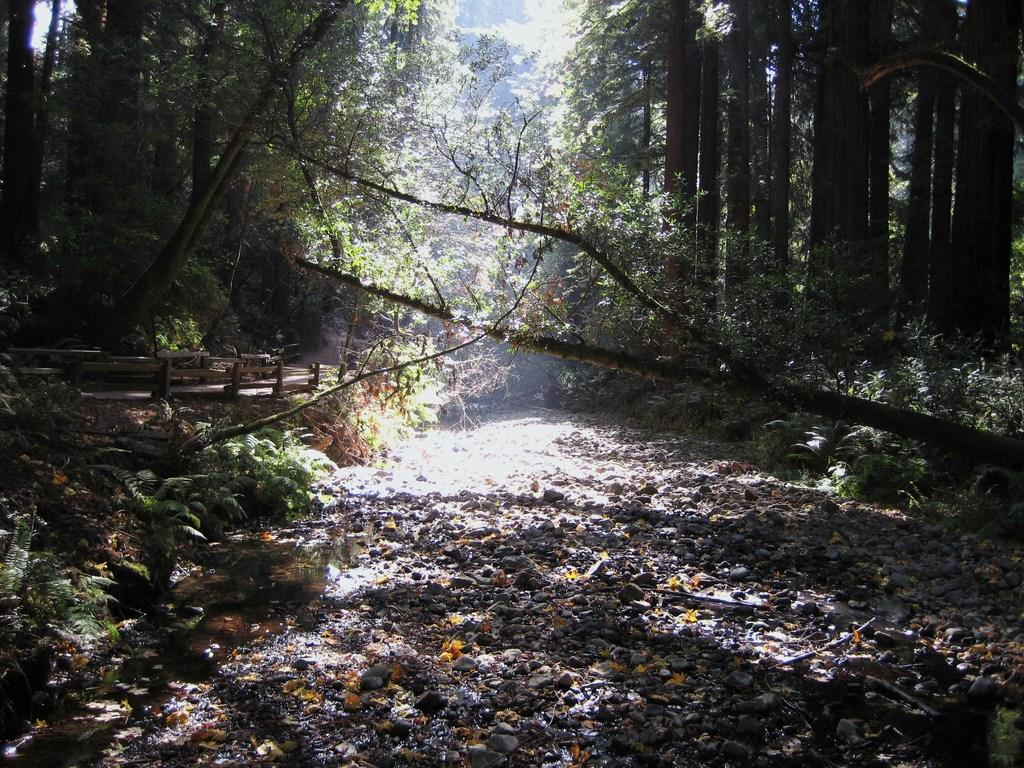What type of vegetation can be seen in the image? There are plants in the image. What can be found on the ground in the image? There are stones on the ground in the image. What is visible in the background of the image? There are trees in the background of the image. What type of dinner is being served in the image? There is no dinner present in the image; it features plants, stones, and trees. Can you tell me how many sticks are visible in the image? There are no sticks visible in the image. 